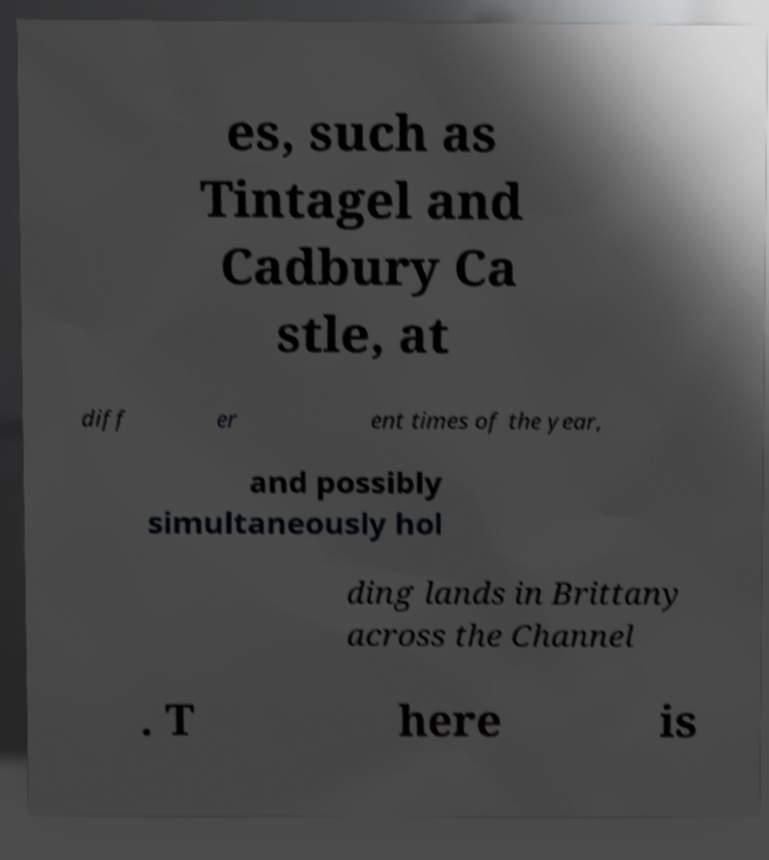Can you accurately transcribe the text from the provided image for me? es, such as Tintagel and Cadbury Ca stle, at diff er ent times of the year, and possibly simultaneously hol ding lands in Brittany across the Channel . T here is 